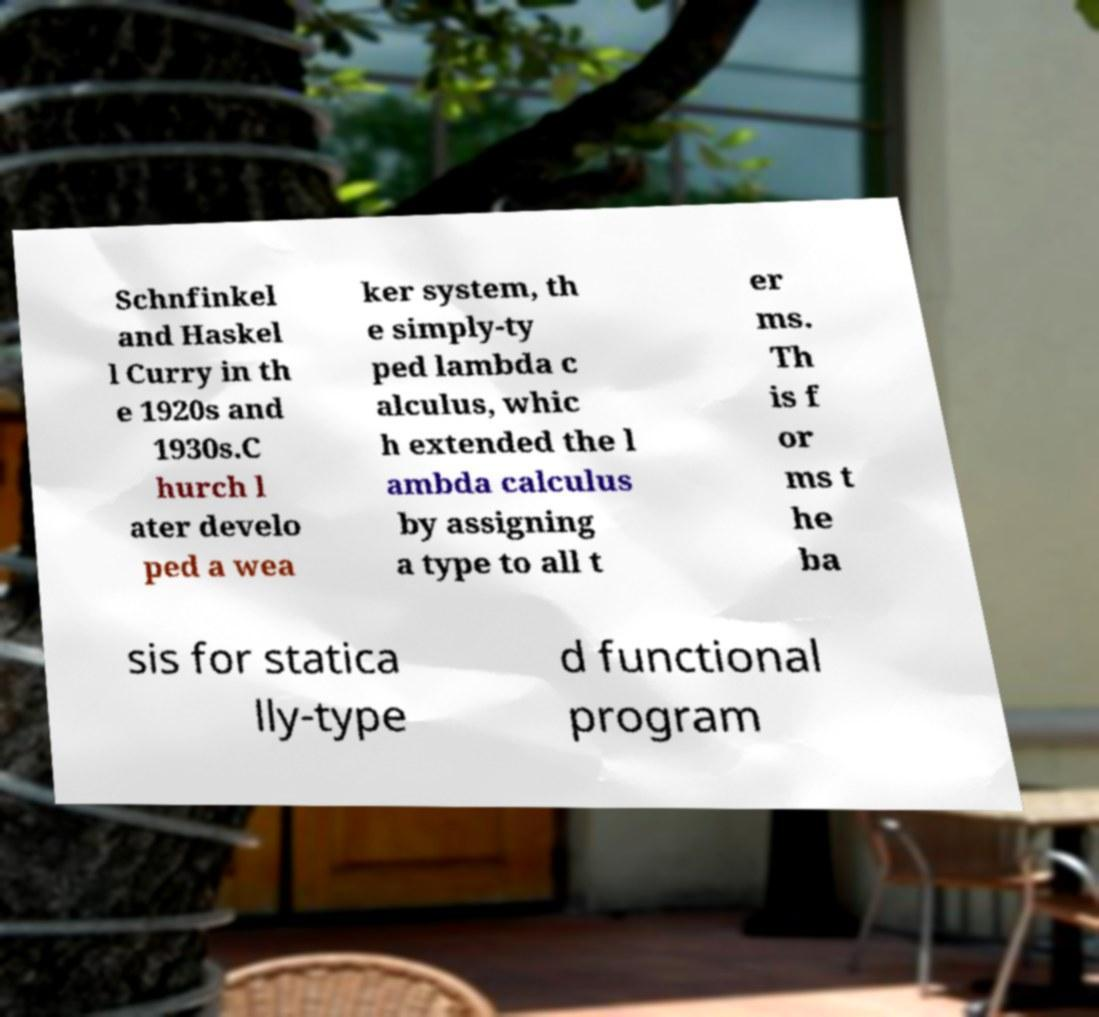Can you accurately transcribe the text from the provided image for me? Schnfinkel and Haskel l Curry in th e 1920s and 1930s.C hurch l ater develo ped a wea ker system, th e simply-ty ped lambda c alculus, whic h extended the l ambda calculus by assigning a type to all t er ms. Th is f or ms t he ba sis for statica lly-type d functional program 